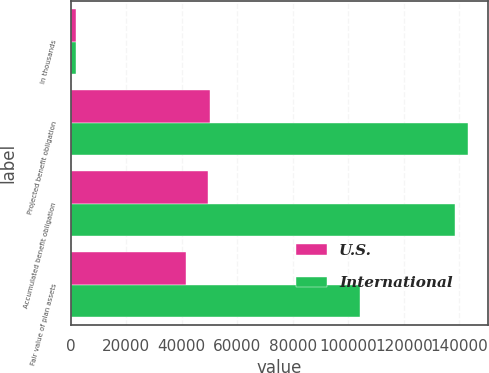Convert chart. <chart><loc_0><loc_0><loc_500><loc_500><stacked_bar_chart><ecel><fcel>In thousands<fcel>Projected benefit obligation<fcel>Accumulated benefit obligation<fcel>Fair value of plan assets<nl><fcel>U.S.<fcel>2014<fcel>50154<fcel>49303<fcel>41503<nl><fcel>International<fcel>2014<fcel>143121<fcel>138443<fcel>104232<nl></chart> 